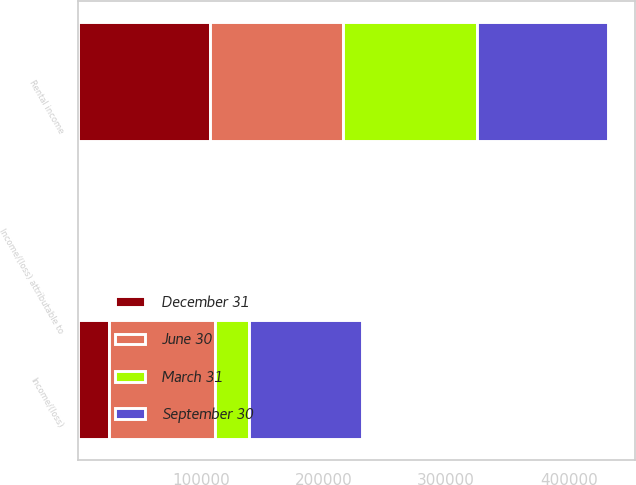Convert chart. <chart><loc_0><loc_0><loc_500><loc_500><stacked_bar_chart><ecel><fcel>Rental income<fcel>Income/(loss)<fcel>Income/(loss) attributable to<nl><fcel>September 30<fcel>106592<fcel>91845<fcel>0.5<nl><fcel>December 31<fcel>107266<fcel>25181<fcel>0.13<nl><fcel>March 31<fcel>109539<fcel>28135<fcel>0.15<nl><fcel>June 30<fcel>108523<fcel>86324<fcel>0.47<nl></chart> 